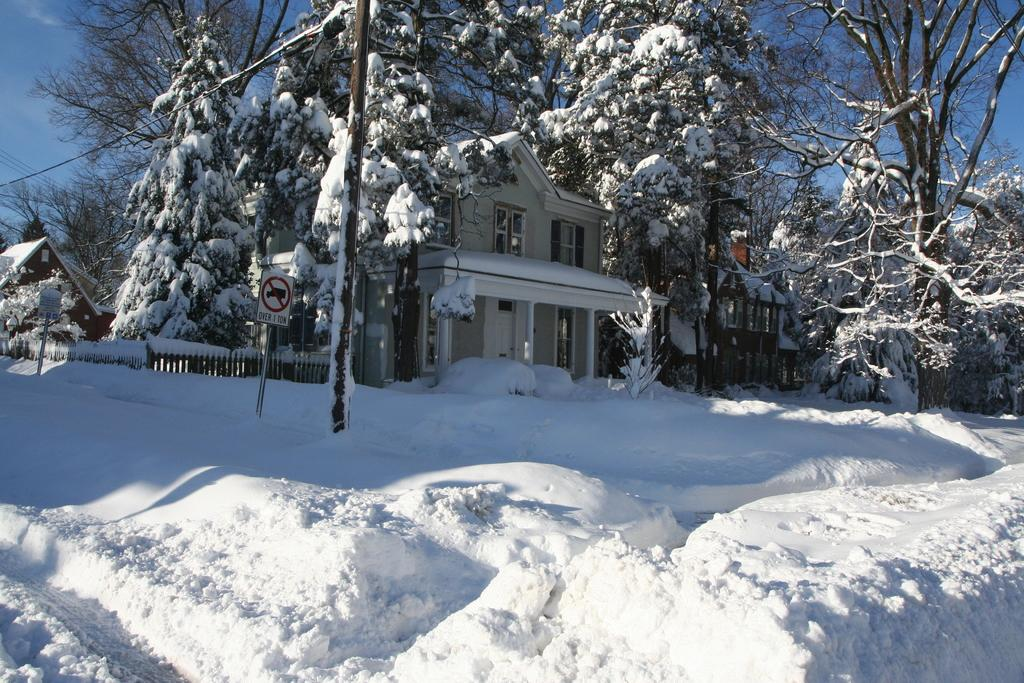What is the predominant weather condition in the image? There is snow in the image, indicating a cold and wintry condition. What type of natural elements can be seen in the image? There are trees in the image. What man-made structures are visible in the image? There are buildings in the image. What type of barrier can be seen in the image? There is a fence in the image. What is visible in the background of the image? The sky is visible in the image. What type of cushion is being used to treat the disease in the image? There is no mention of a disease or a cushion in the image; it features snow, trees, buildings, a fence, and the sky. 